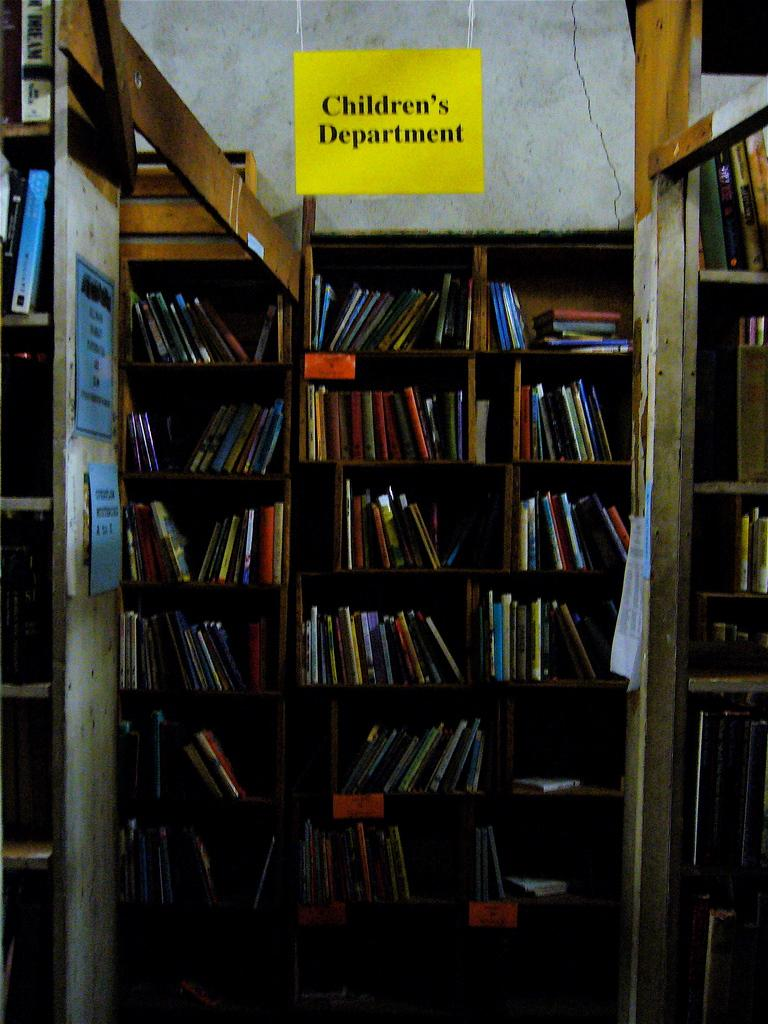<image>
Write a terse but informative summary of the picture. Book store with a yellow sign that says Children's Department. 